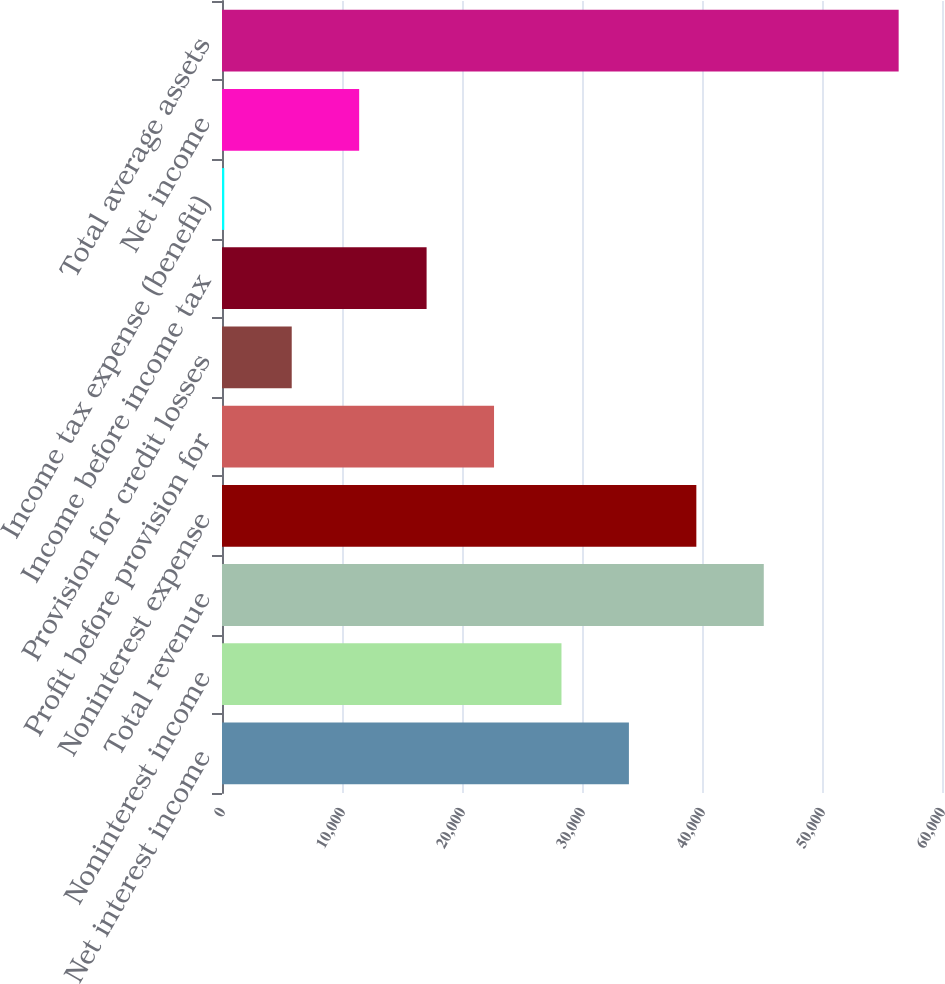Convert chart to OTSL. <chart><loc_0><loc_0><loc_500><loc_500><bar_chart><fcel>Net interest income<fcel>Noninterest income<fcel>Total revenue<fcel>Noninterest expense<fcel>Profit before provision for<fcel>Provision for credit losses<fcel>Income before income tax<fcel>Income tax expense (benefit)<fcel>Net income<fcel>Total average assets<nl><fcel>33909.2<fcel>28289.5<fcel>45148.6<fcel>39528.9<fcel>22669.8<fcel>5810.7<fcel>17050.1<fcel>191<fcel>11430.4<fcel>56388<nl></chart> 